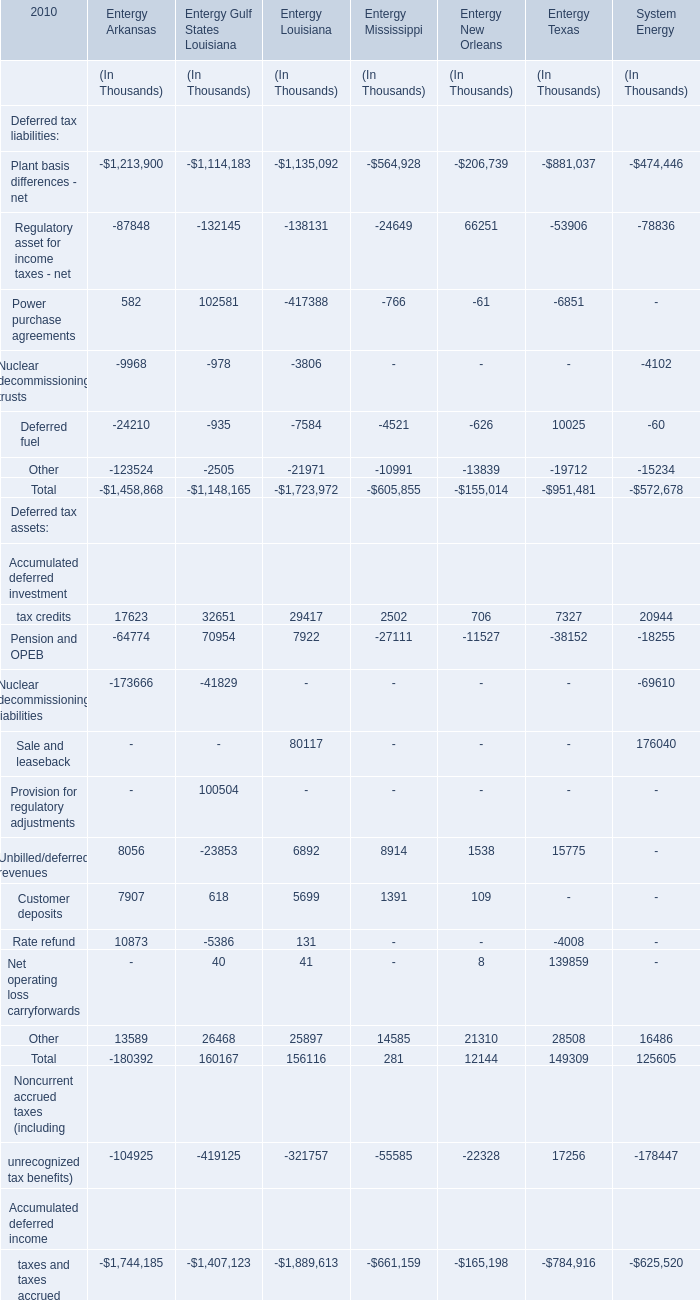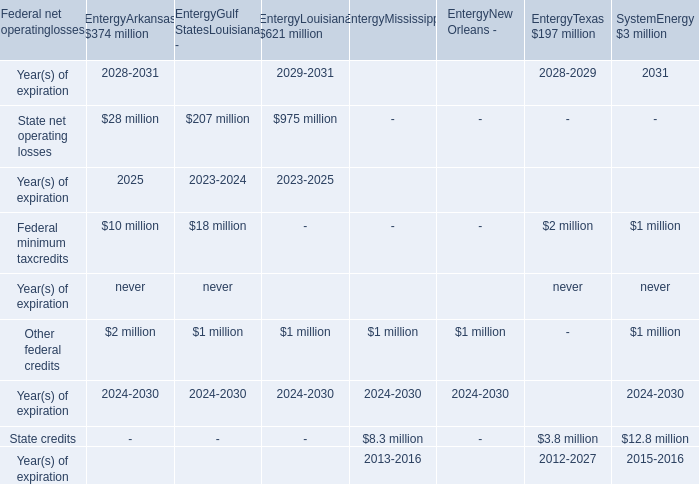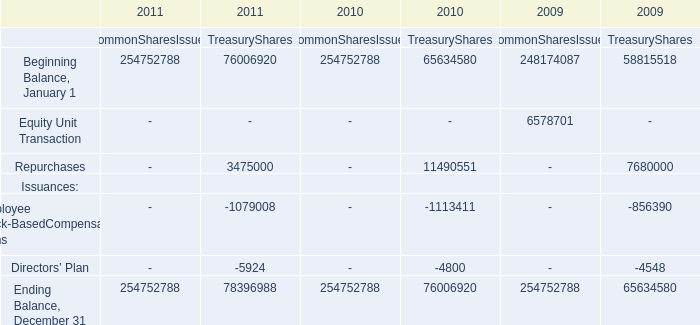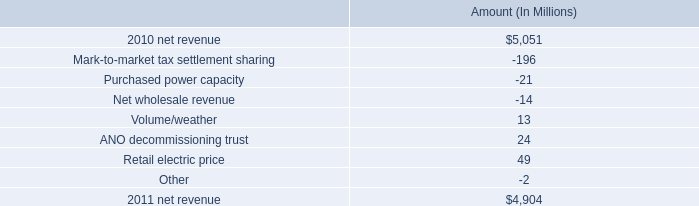What was the average of Other of Deferred tax assets for Entergy Arkansas, Entergy Louisiana, and Entergy Mississippi ? (in thousand) 
Computations: (((13589 + 25897) + 14585) / 3)
Answer: 18023.66667. 